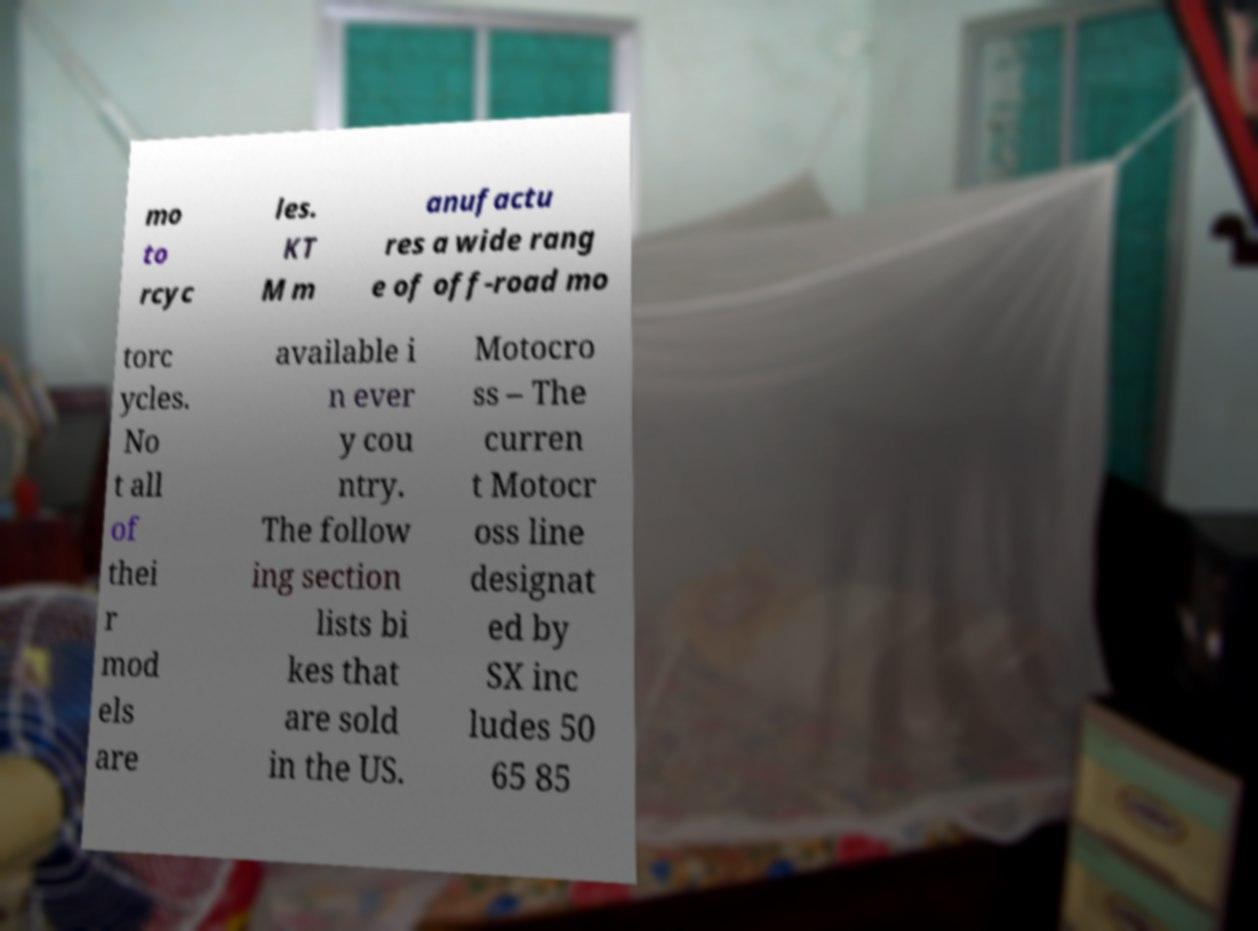There's text embedded in this image that I need extracted. Can you transcribe it verbatim? mo to rcyc les. KT M m anufactu res a wide rang e of off-road mo torc ycles. No t all of thei r mod els are available i n ever y cou ntry. The follow ing section lists bi kes that are sold in the US. Motocro ss – The curren t Motocr oss line designat ed by SX inc ludes 50 65 85 